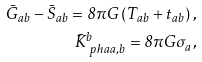<formula> <loc_0><loc_0><loc_500><loc_500>\bar { G } _ { a b } - \bar { S } _ { a b } = 8 \pi G \left ( T _ { a b } + t _ { a b } \right ) , \\ \bar { K } ^ { b } _ { \ p h { a } a , b } = 8 \pi G \sigma _ { a } ,</formula> 